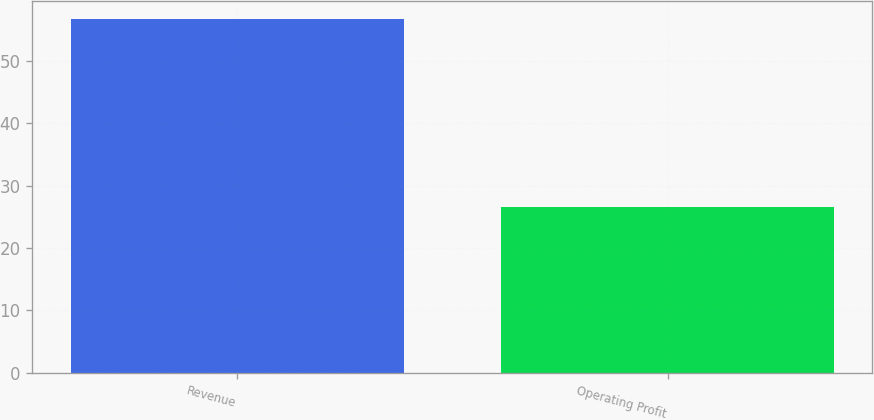Convert chart. <chart><loc_0><loc_0><loc_500><loc_500><bar_chart><fcel>Revenue<fcel>Operating Profit<nl><fcel>56.7<fcel>26.6<nl></chart> 